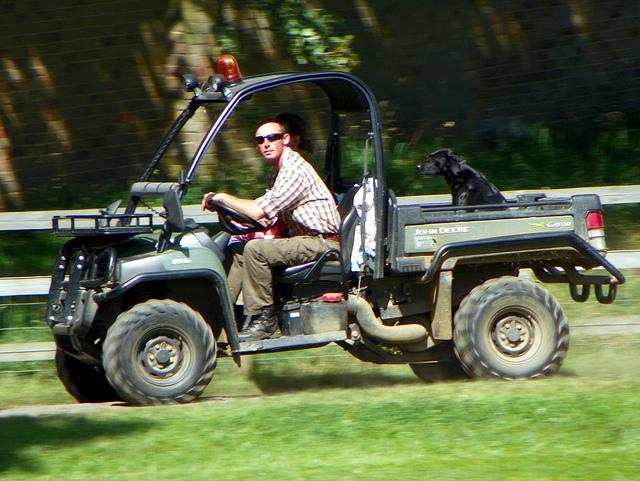Why is the dog in the back? Please explain your reasoning. no room. There is ample space for the dog in the back. 